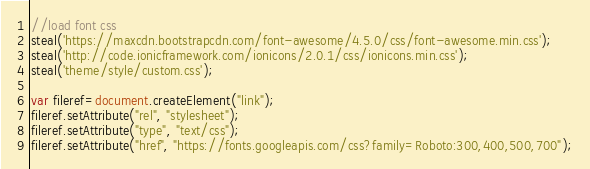Convert code to text. <code><loc_0><loc_0><loc_500><loc_500><_JavaScript_>//load font css
steal('https://maxcdn.bootstrapcdn.com/font-awesome/4.5.0/css/font-awesome.min.css');
steal('http://code.ionicframework.com/ionicons/2.0.1/css/ionicons.min.css');
steal('theme/style/custom.css');

var fileref=document.createElement("link");
fileref.setAttribute("rel", "stylesheet");
fileref.setAttribute("type", "text/css");
fileref.setAttribute("href", "https://fonts.googleapis.com/css?family=Roboto:300,400,500,700");


</code> 